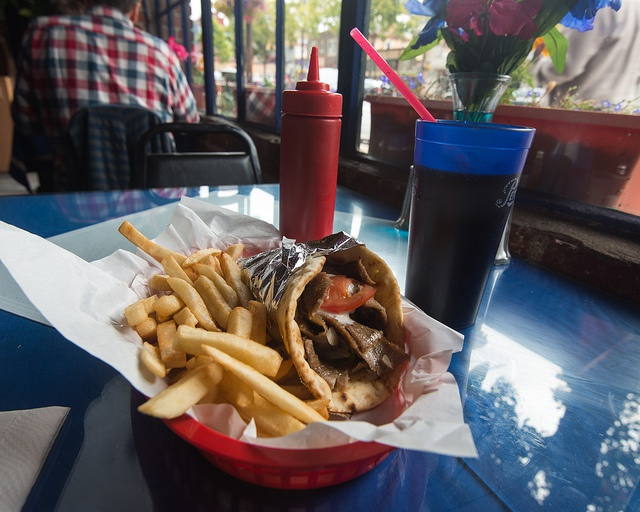Describe the objects in this image and their specific colors. I can see dining table in black, lightgray, maroon, and darkgray tones, sandwich in black, maroon, and brown tones, cup in black, navy, darkblue, and gray tones, people in black, gray, darkgray, and maroon tones, and people in black, darkgray, lightgray, and gray tones in this image. 